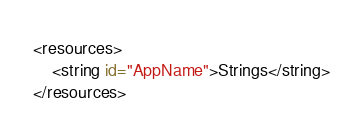Convert code to text. <code><loc_0><loc_0><loc_500><loc_500><_XML_><resources>
    <string id="AppName">Strings</string>
</resources></code> 